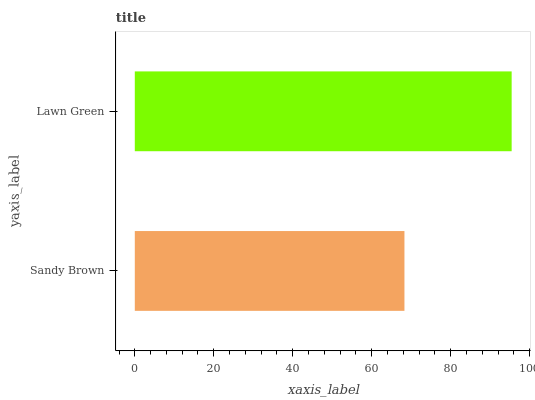Is Sandy Brown the minimum?
Answer yes or no. Yes. Is Lawn Green the maximum?
Answer yes or no. Yes. Is Lawn Green the minimum?
Answer yes or no. No. Is Lawn Green greater than Sandy Brown?
Answer yes or no. Yes. Is Sandy Brown less than Lawn Green?
Answer yes or no. Yes. Is Sandy Brown greater than Lawn Green?
Answer yes or no. No. Is Lawn Green less than Sandy Brown?
Answer yes or no. No. Is Lawn Green the high median?
Answer yes or no. Yes. Is Sandy Brown the low median?
Answer yes or no. Yes. Is Sandy Brown the high median?
Answer yes or no. No. Is Lawn Green the low median?
Answer yes or no. No. 